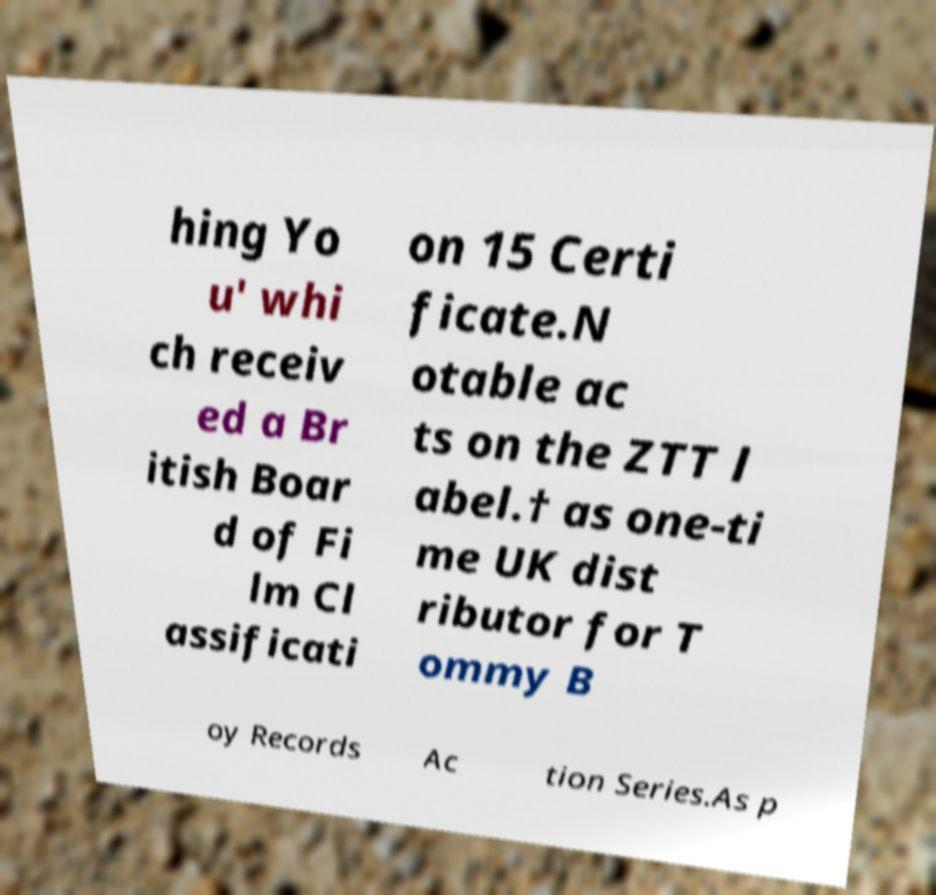Please identify and transcribe the text found in this image. hing Yo u' whi ch receiv ed a Br itish Boar d of Fi lm Cl assificati on 15 Certi ficate.N otable ac ts on the ZTT l abel.† as one-ti me UK dist ributor for T ommy B oy Records Ac tion Series.As p 